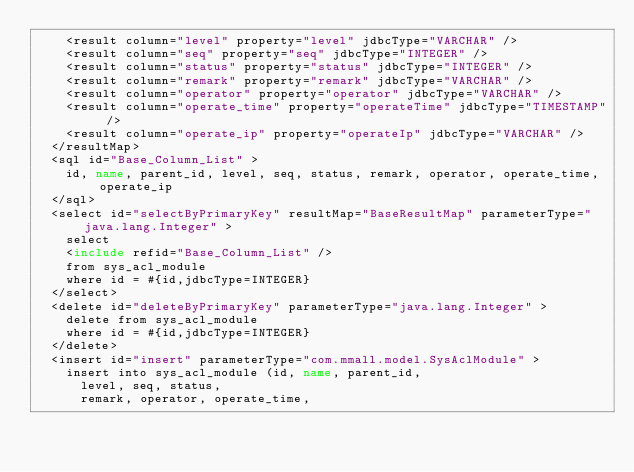<code> <loc_0><loc_0><loc_500><loc_500><_XML_>    <result column="level" property="level" jdbcType="VARCHAR" />
    <result column="seq" property="seq" jdbcType="INTEGER" />
    <result column="status" property="status" jdbcType="INTEGER" />
    <result column="remark" property="remark" jdbcType="VARCHAR" />
    <result column="operator" property="operator" jdbcType="VARCHAR" />
    <result column="operate_time" property="operateTime" jdbcType="TIMESTAMP" />
    <result column="operate_ip" property="operateIp" jdbcType="VARCHAR" />
  </resultMap>
  <sql id="Base_Column_List" >
    id, name, parent_id, level, seq, status, remark, operator, operate_time, operate_ip
  </sql>
  <select id="selectByPrimaryKey" resultMap="BaseResultMap" parameterType="java.lang.Integer" >
    select 
    <include refid="Base_Column_List" />
    from sys_acl_module
    where id = #{id,jdbcType=INTEGER}
  </select>
  <delete id="deleteByPrimaryKey" parameterType="java.lang.Integer" >
    delete from sys_acl_module
    where id = #{id,jdbcType=INTEGER}
  </delete>
  <insert id="insert" parameterType="com.mmall.model.SysAclModule" >
    insert into sys_acl_module (id, name, parent_id, 
      level, seq, status, 
      remark, operator, operate_time, </code> 